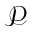<formula> <loc_0><loc_0><loc_500><loc_500>\ m a t h s c r { P }</formula> 